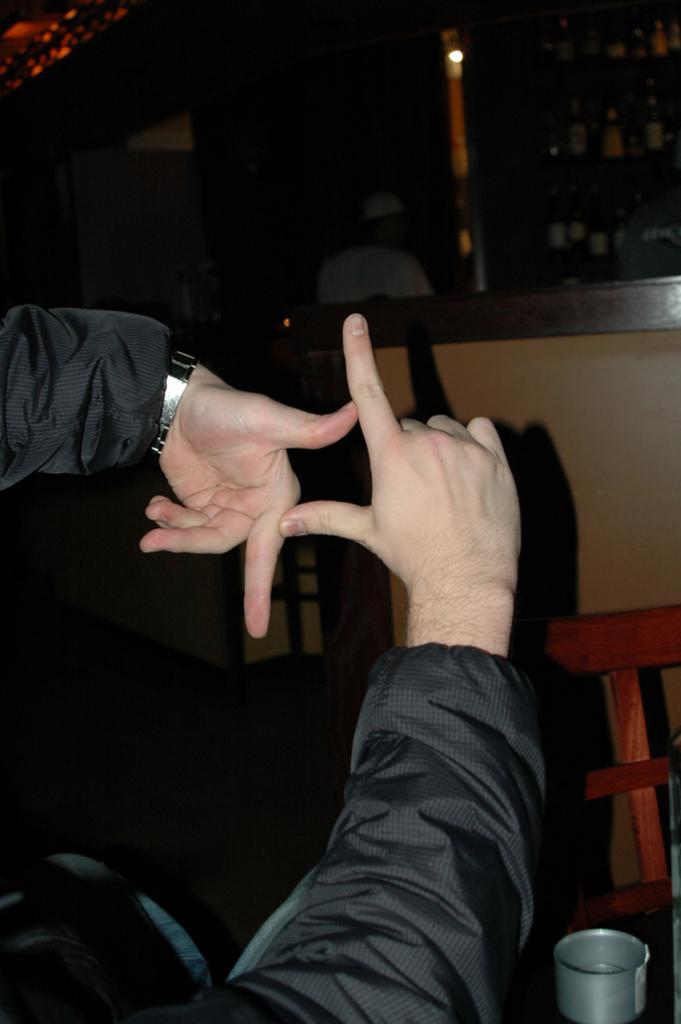Describe this image in one or two sentences. In this image we can see the human hands, chair, tin, walls and a mirror. 